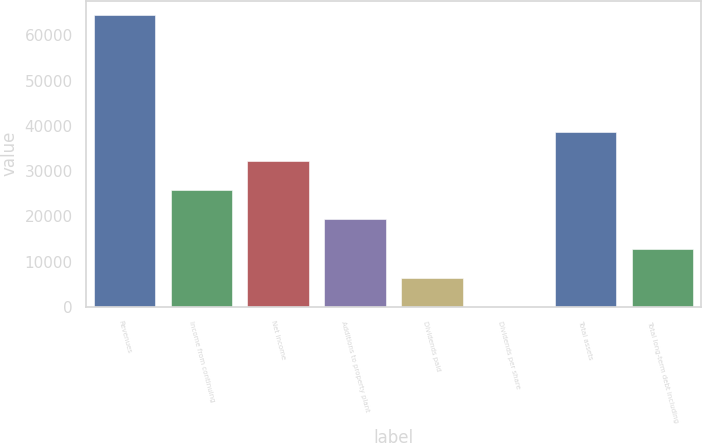<chart> <loc_0><loc_0><loc_500><loc_500><bar_chart><fcel>Revenues<fcel>Income from continuing<fcel>Net income<fcel>Additions to property plant<fcel>Dividends paid<fcel>Dividends per share<fcel>Total assets<fcel>Total long-term debt including<nl><fcel>64439<fcel>25776<fcel>32219.9<fcel>19332.2<fcel>6444.58<fcel>0.76<fcel>38663.7<fcel>12888.4<nl></chart> 